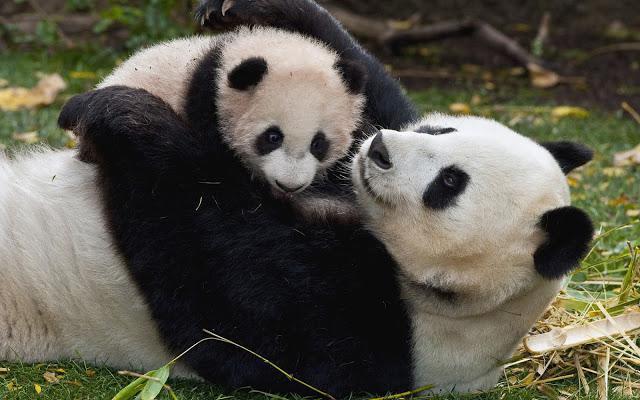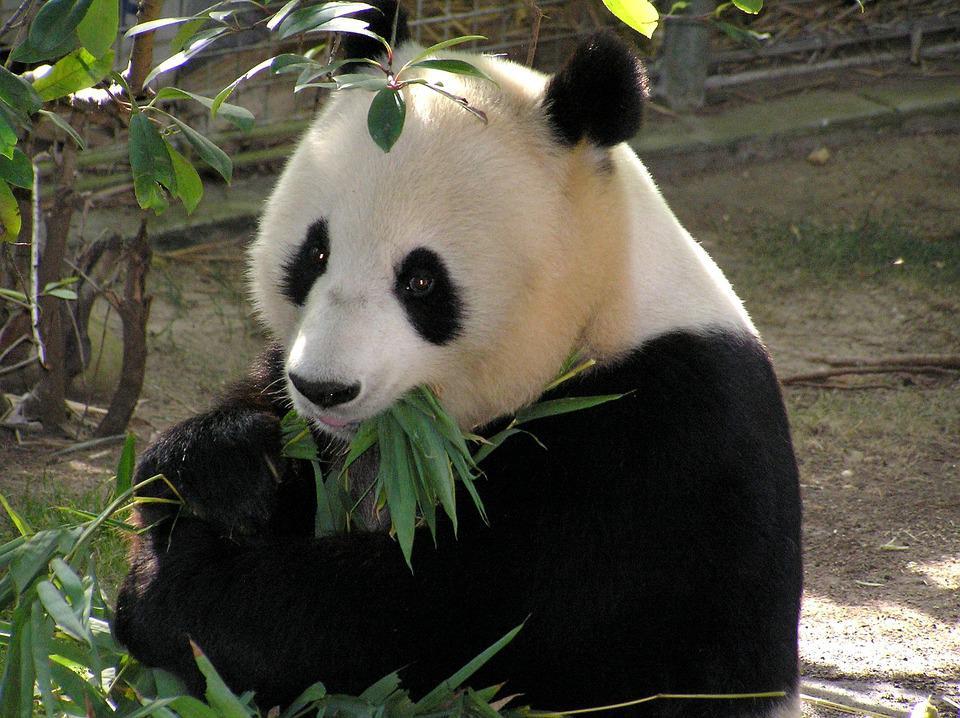The first image is the image on the left, the second image is the image on the right. For the images displayed, is the sentence "There are two pandas in the image on the right." factually correct? Answer yes or no. No. 